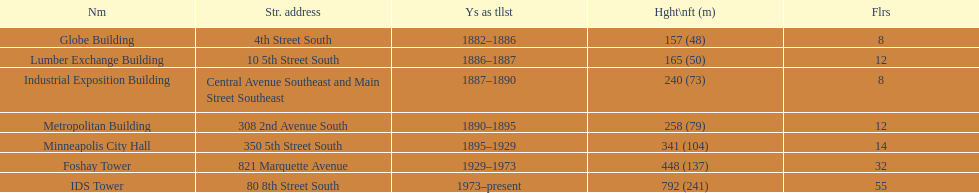After ids tower what is the second tallest building in minneapolis? Foshay Tower. 